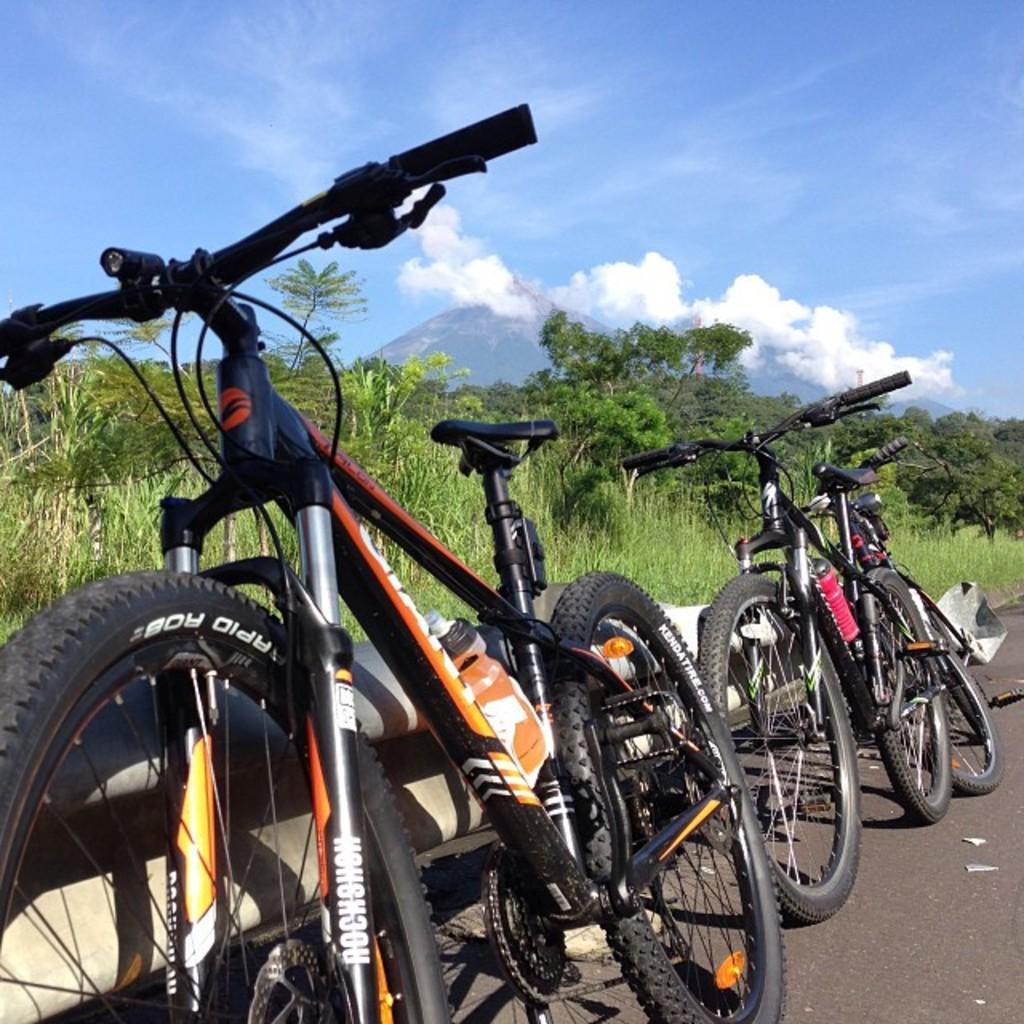Describe this image in one or two sentences. In the image there are two bicycles on the side of the road and behind it there are trees all over the image and above its sky with clouds. 